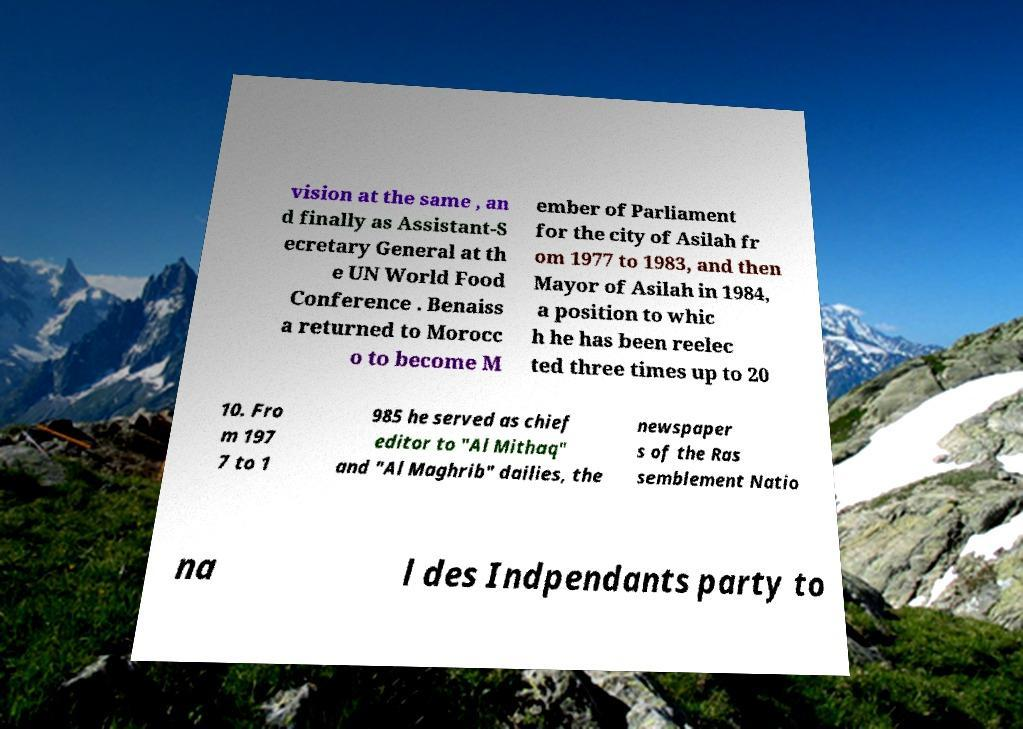I need the written content from this picture converted into text. Can you do that? vision at the same , an d finally as Assistant-S ecretary General at th e UN World Food Conference . Benaiss a returned to Morocc o to become M ember of Parliament for the city of Asilah fr om 1977 to 1983, and then Mayor of Asilah in 1984, a position to whic h he has been reelec ted three times up to 20 10. Fro m 197 7 to 1 985 he served as chief editor to "Al Mithaq" and "Al Maghrib" dailies, the newspaper s of the Ras semblement Natio na l des Indpendants party to 